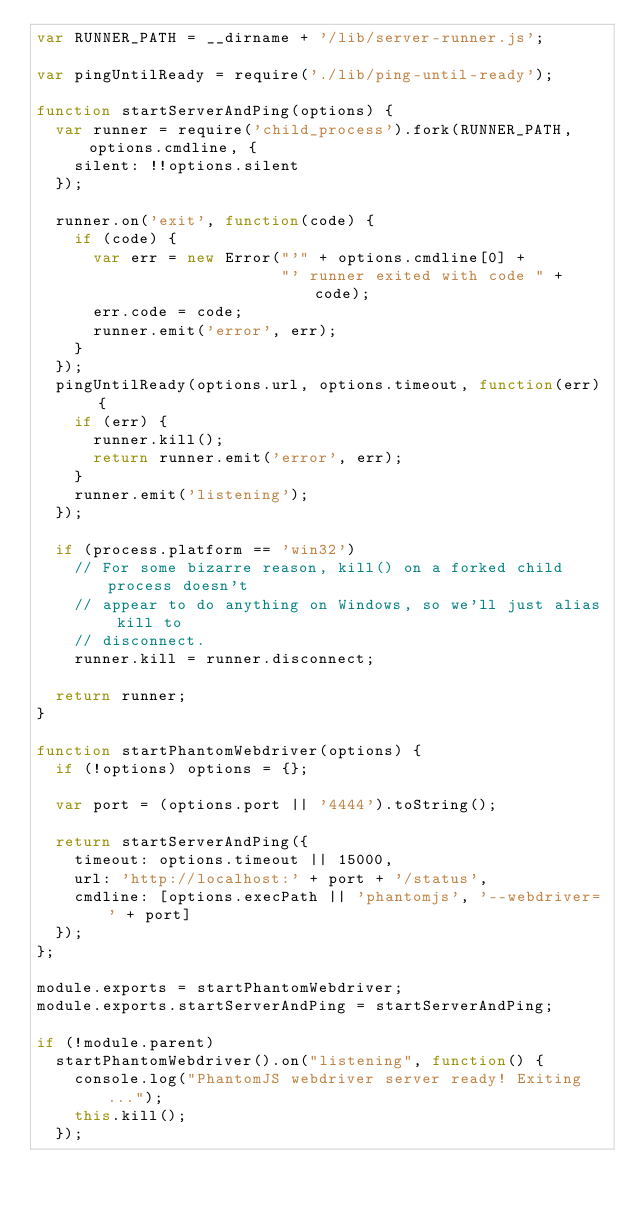<code> <loc_0><loc_0><loc_500><loc_500><_JavaScript_>var RUNNER_PATH = __dirname + '/lib/server-runner.js';

var pingUntilReady = require('./lib/ping-until-ready');

function startServerAndPing(options) {
  var runner = require('child_process').fork(RUNNER_PATH, options.cmdline, {
    silent: !!options.silent
  });

  runner.on('exit', function(code) {
    if (code) {
      var err = new Error("'" + options.cmdline[0] +
                          "' runner exited with code " + code);
      err.code = code;
      runner.emit('error', err);
    }
  });
  pingUntilReady(options.url, options.timeout, function(err) {
    if (err) {
      runner.kill();
      return runner.emit('error', err);
    }
    runner.emit('listening');
  });

  if (process.platform == 'win32')
    // For some bizarre reason, kill() on a forked child process doesn't
    // appear to do anything on Windows, so we'll just alias kill to
    // disconnect.
    runner.kill = runner.disconnect;

  return runner;
}

function startPhantomWebdriver(options) {
  if (!options) options = {};

  var port = (options.port || '4444').toString();

  return startServerAndPing({
    timeout: options.timeout || 15000,
    url: 'http://localhost:' + port + '/status',
    cmdline: [options.execPath || 'phantomjs', '--webdriver=' + port]
  });
};

module.exports = startPhantomWebdriver;
module.exports.startServerAndPing = startServerAndPing;

if (!module.parent)
  startPhantomWebdriver().on("listening", function() {
    console.log("PhantomJS webdriver server ready! Exiting...");
    this.kill();
  });
</code> 